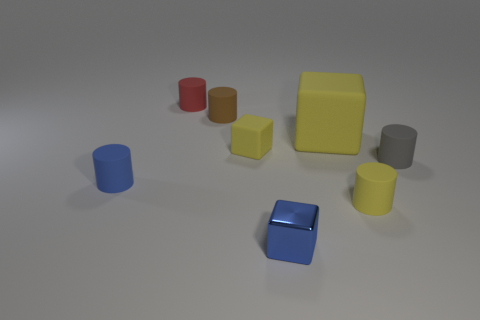Subtract all yellow cubes. How many cubes are left? 1 Subtract 5 cylinders. How many cylinders are left? 0 Subtract all gray cylinders. How many cylinders are left? 4 Subtract all red cylinders. How many yellow cubes are left? 2 Add 1 large brown blocks. How many objects exist? 9 Add 1 blue cubes. How many blue cubes are left? 2 Add 8 tiny brown shiny cylinders. How many tiny brown shiny cylinders exist? 8 Subtract 0 yellow balls. How many objects are left? 8 Subtract all cylinders. How many objects are left? 3 Subtract all red cylinders. Subtract all brown blocks. How many cylinders are left? 4 